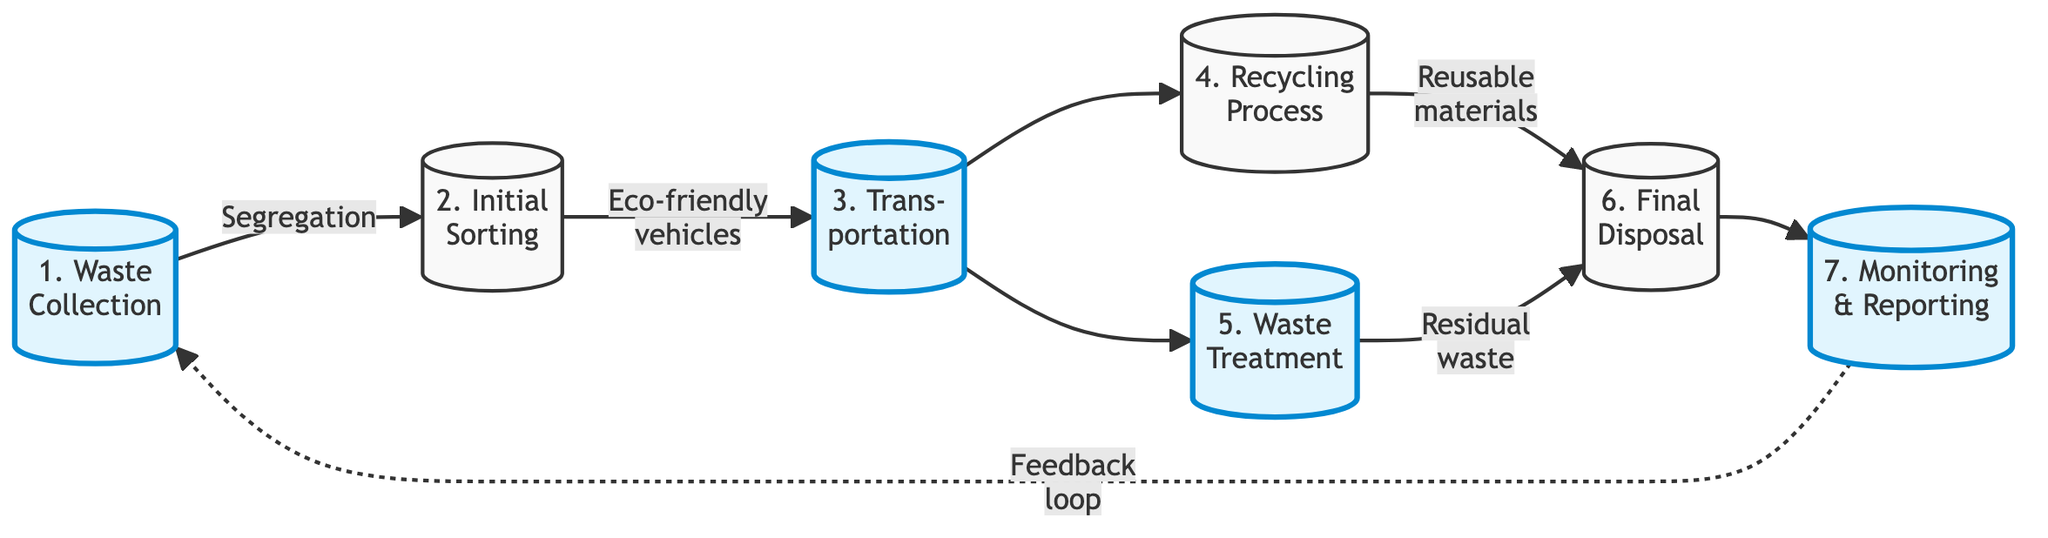What is the first step in the waste management workflow? The first step in the diagram is labeled as "1. Waste Collection." This represents the beginning of the process where waste materials are gathered from various factory departments.
Answer: Waste Collection How many steps are there in the waste management workflow? The diagram outlines a total of 7 distinct steps ranging from Waste Collection to Monitoring and Reporting. By counting the listed steps, we find there are seven in total.
Answer: 7 What type of vehicles is used for transportation in this workflow? Referring to the edge connecting Initial Sorting to Transportation, the diagram specifies the use of "eco-friendly vehicles" for the transfer of sorted waste.
Answer: Eco-friendly vehicles Which step involves the treatment of non-recyclable waste? The diagram indicates that "5. Waste Treatment" is the step specifically dedicated to treating non-recyclable waste to minimize its environmental impact.
Answer: Waste Treatment What do the final disposal step and the recycling process have in common? Both steps result in material handling; the Recycling Process converts recyclable materials into reusable raw materials, and Final Disposal deals with the residual waste processed from both recycling and waste treatment procedures. This gives insight into both steps contributing to managing waste effectively.
Answer: Material handling Which step has a feedback loop to the waste collection process? The dashed line indicates a feedback loop from "7. Monitoring and Reporting" back to "1. Waste Collection." This illustrates that monitoring outcomes can inform future waste collection practices.
Answer: Monitoring and Reporting What are the two outcomes from the recycling process? The Recycling Process leads to two possible outcomes: "Reusable materials" which contribute to sustainability initiatives and are sent to Final Disposal for any residual waste generated.
Answer: Reusable materials and Residual waste 